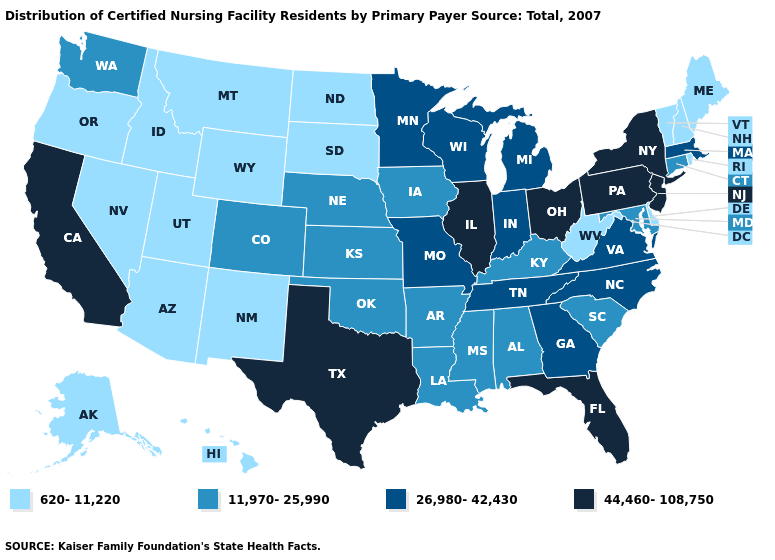What is the value of New York?
Answer briefly. 44,460-108,750. Name the states that have a value in the range 44,460-108,750?
Give a very brief answer. California, Florida, Illinois, New Jersey, New York, Ohio, Pennsylvania, Texas. Among the states that border Georgia , which have the highest value?
Write a very short answer. Florida. Which states have the lowest value in the West?
Answer briefly. Alaska, Arizona, Hawaii, Idaho, Montana, Nevada, New Mexico, Oregon, Utah, Wyoming. What is the value of New Mexico?
Write a very short answer. 620-11,220. What is the value of Arizona?
Answer briefly. 620-11,220. What is the value of West Virginia?
Short answer required. 620-11,220. Does the first symbol in the legend represent the smallest category?
Quick response, please. Yes. What is the lowest value in the Northeast?
Give a very brief answer. 620-11,220. What is the value of Iowa?
Short answer required. 11,970-25,990. Does Maine have a lower value than Hawaii?
Answer briefly. No. What is the lowest value in states that border South Carolina?
Quick response, please. 26,980-42,430. What is the lowest value in states that border Minnesota?
Be succinct. 620-11,220. Does Delaware have the lowest value in the South?
Be succinct. Yes. What is the lowest value in the USA?
Answer briefly. 620-11,220. 